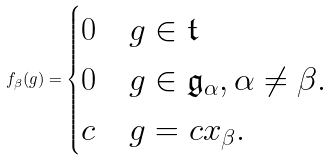<formula> <loc_0><loc_0><loc_500><loc_500>f _ { \beta } ( g ) = \begin{cases} 0 & g \in \mathfrak { t } \\ 0 & g \in \mathfrak { g } _ { \alpha } , \alpha \neq \beta . \\ c & g = c x _ { \beta } . \end{cases}</formula> 